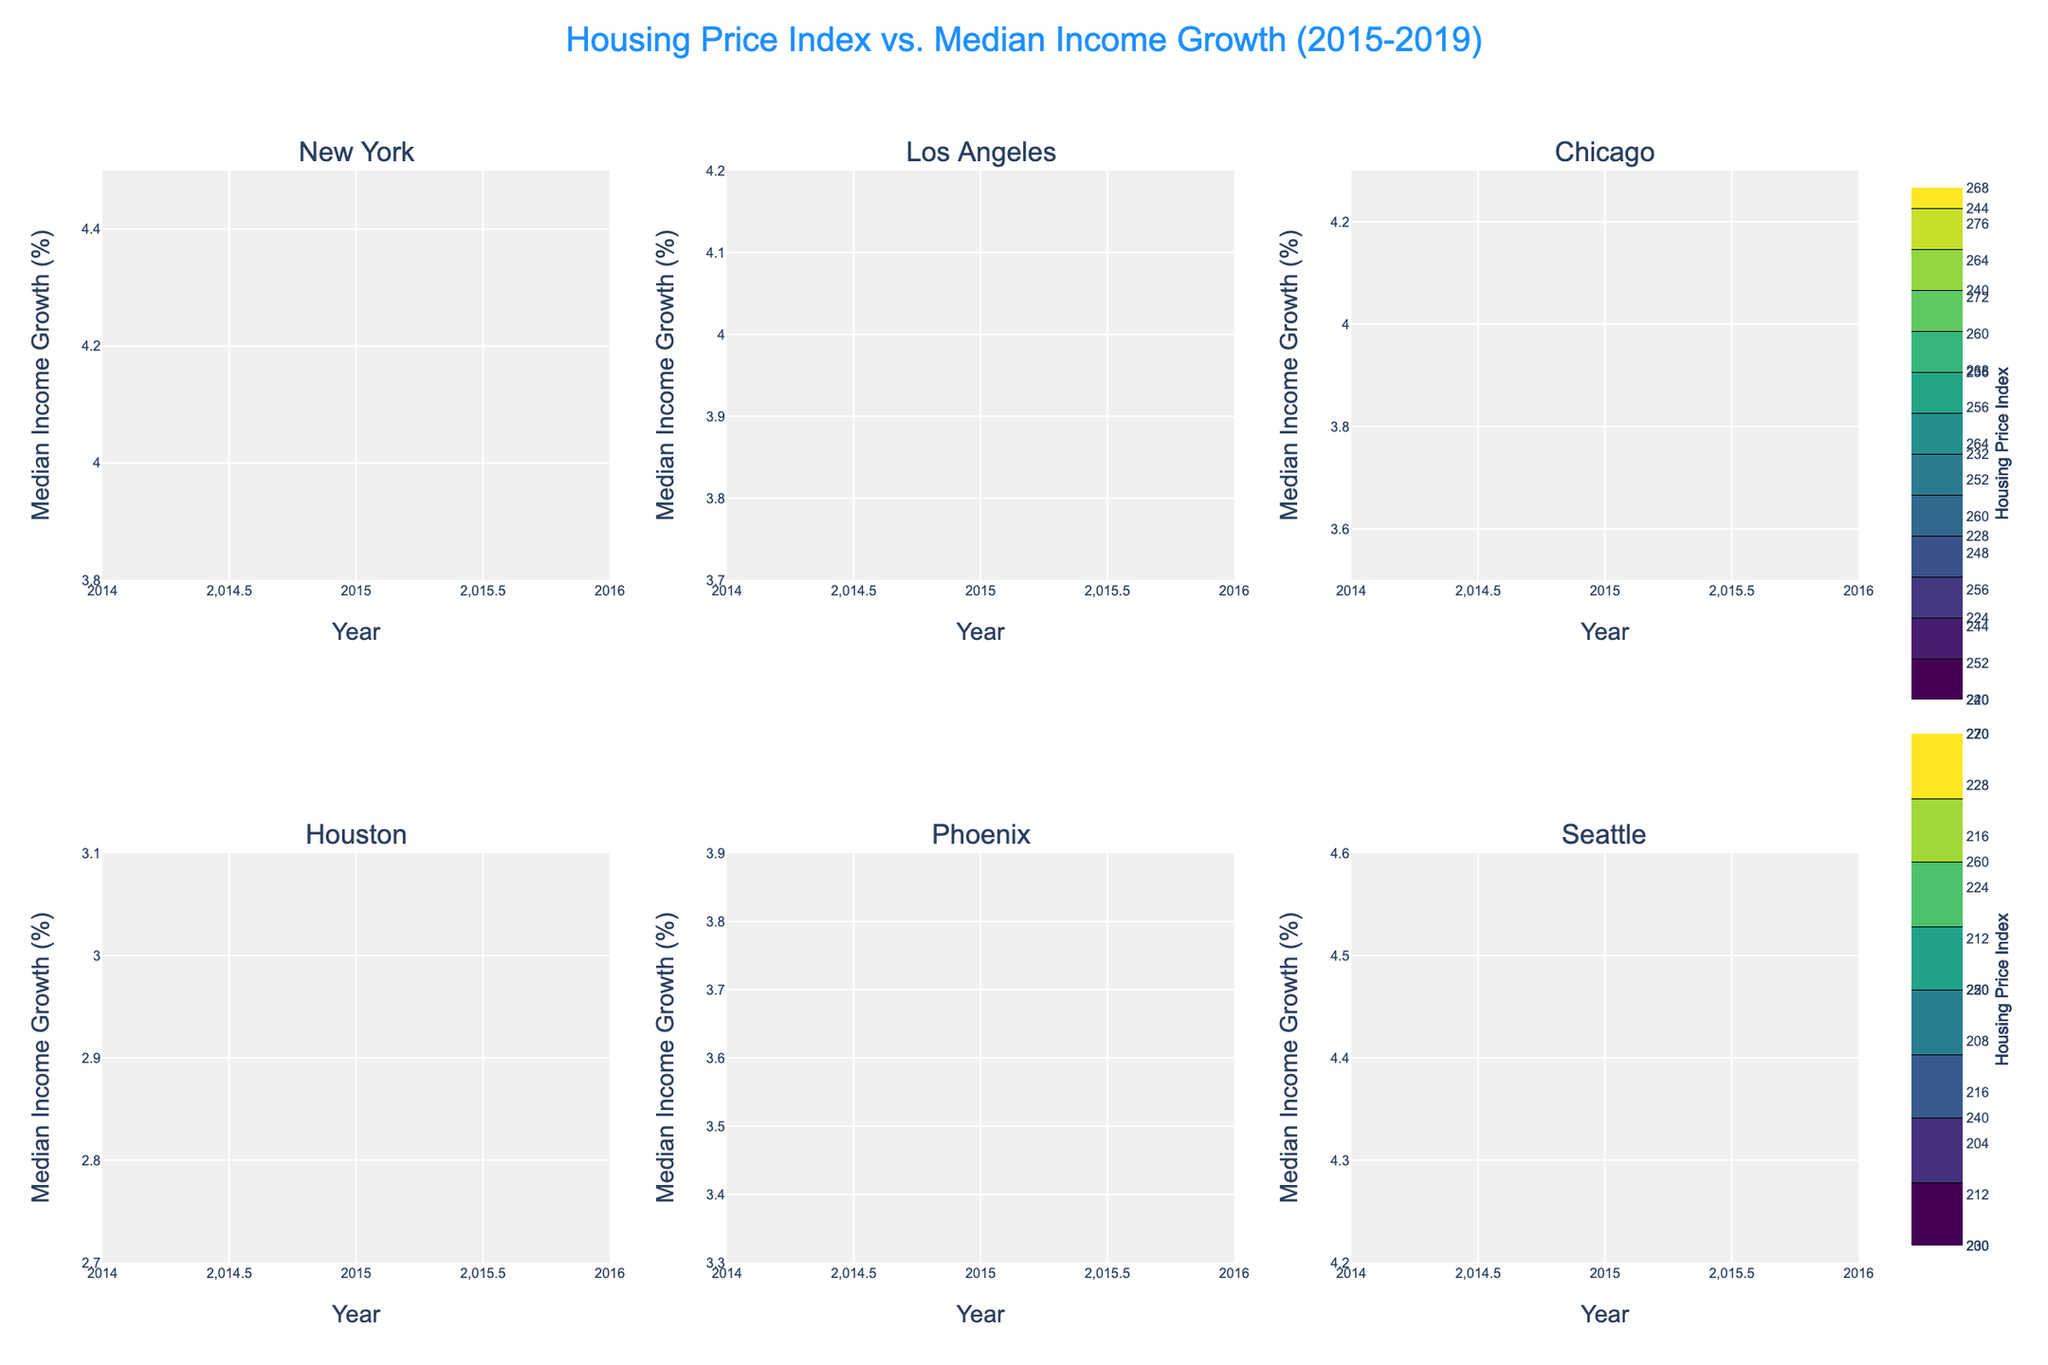What is the title of the figure? The title is located at the top center of the figure and is intended to give a summary description of what the figure represents. Based on the provided details, it reads "Housing Price Index vs. Median Income Growth (2015-2019)".
Answer: Housing Price Index vs. Median Income Growth (2015-2019) How many cities are compared in this figure? By looking at the subplot titles within the figure, there are multiple unique subplots each representing a different city. By counting these titles, we find there are six cities being compared.
Answer: Six Which city shows the highest Median Income Growth in 2019? To answer this, locate each subplot for the year 2019, then find which has the highest y-axis value representing Median Income Growth. The Seattle subplot shows the highest value at around 4.4%.
Answer: Seattle Between New York and Los Angeles in 2018, which city had a higher Housing Price Index? Look at the contour lines and their values in the subplots for New York and Los Angeles for the year 2018. The Housing Price Index in New York for 2018 is 270, while in Los Angeles it is 260.
Answer: New York What trend is visible for Houston's Housing Price Index from 2015 to 2019? From the Houston subplot, observe the values along the x-axis (years) and see how the z-values (Housing Price Index) change. From 2015 to 2019, Houston's Housing Price Index shows a steady increase from 210 to 230.
Answer: Increasing How does the Median Income Growth of Phoenix in 2017 compare to that of Chicago the same year? Examine the y-axis values for the subplots of Phoenix and Chicago in the year 2017. Median Income Growth in Phoenix is 3.9% and in Chicago it is also 3.9%, making them equal.
Answer: Equal On average, which city had the highest Housing Price Index over the five years? To determine this, calculate the average Housing Price Index for each city over the years 2015-2019. Summing and averaging the values: New York (263), Los Angeles (253.6), Chicago (234), Houston (220), Phoenix (210), Seattle (250). New York has the highest average.
Answer: New York 